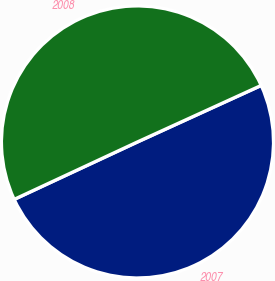Convert chart. <chart><loc_0><loc_0><loc_500><loc_500><pie_chart><fcel>2007<fcel>2008<nl><fcel>49.88%<fcel>50.12%<nl></chart> 